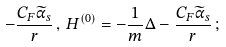<formula> <loc_0><loc_0><loc_500><loc_500>- \frac { C _ { F } { \widetilde { \alpha } _ { s } } } { r } \, , \, H ^ { ( 0 ) } = - \frac { 1 } { m } \Delta - \frac { C _ { F } { \widetilde { \alpha } _ { s } } } { r } \, ; \,</formula> 